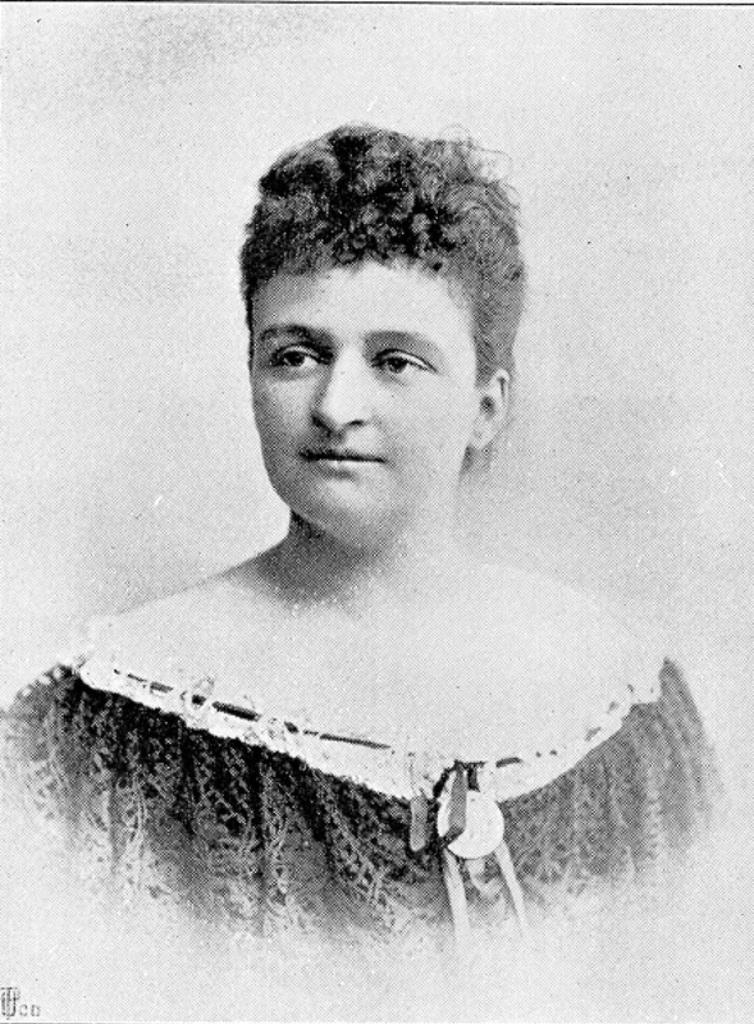What is the color scheme of the image? The image is black and white. Can you describe the main subject in the image? There is a lady in the image. Where is the faucet located in the image? There is no faucet present in the image. What does the lady say to bid farewell in the image? The image is black and white and does not contain any dialogue or sound, so it is not possible to determine what the lady might say. 